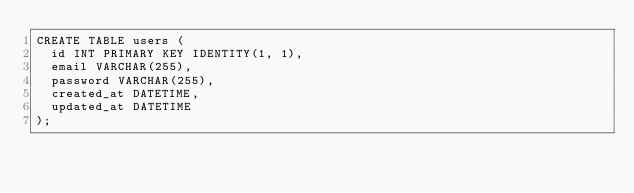Convert code to text. <code><loc_0><loc_0><loc_500><loc_500><_SQL_>CREATE TABLE users (
  id INT PRIMARY KEY IDENTITY(1, 1),
  email VARCHAR(255),
  password VARCHAR(255),
  created_at DATETIME,
  updated_at DATETIME
);
</code> 